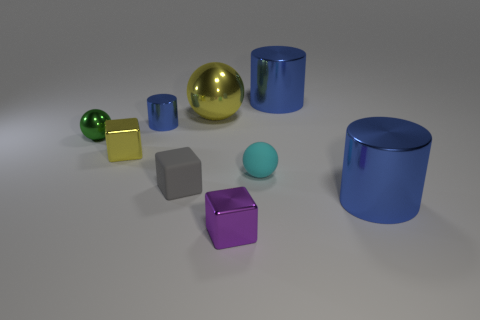What color is the metal cylinder that is both behind the small yellow shiny cube and in front of the yellow ball?
Your answer should be very brief. Blue. Do the gray matte cube and the blue metal object that is behind the big yellow ball have the same size?
Your response must be concise. No. Is there any other thing that is the same shape as the tiny green object?
Provide a succinct answer. Yes. What color is the big metal thing that is the same shape as the cyan matte thing?
Offer a very short reply. Yellow. Does the green metal thing have the same size as the matte cube?
Ensure brevity in your answer.  Yes. How many other objects are there of the same size as the cyan ball?
Offer a terse response. 5. How many things are either tiny blocks that are behind the tiny purple metallic cube or blue cylinders behind the small blue cylinder?
Your answer should be very brief. 3. There is a cyan matte object that is the same size as the green sphere; what shape is it?
Offer a terse response. Sphere. The yellow object that is made of the same material as the yellow ball is what size?
Provide a succinct answer. Small. Is the cyan object the same shape as the small yellow metallic object?
Provide a short and direct response. No. 